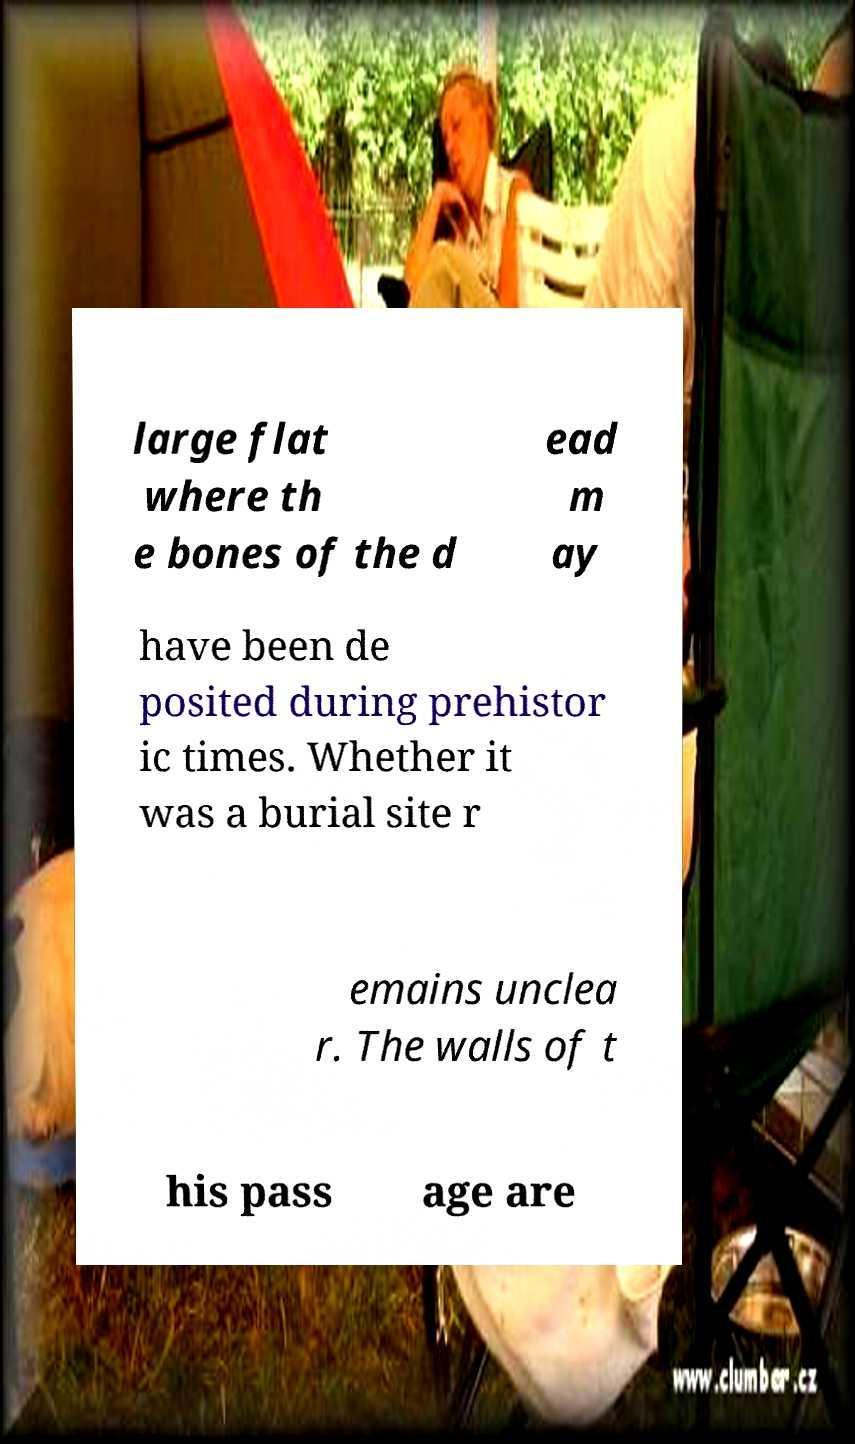Could you extract and type out the text from this image? large flat where th e bones of the d ead m ay have been de posited during prehistor ic times. Whether it was a burial site r emains unclea r. The walls of t his pass age are 